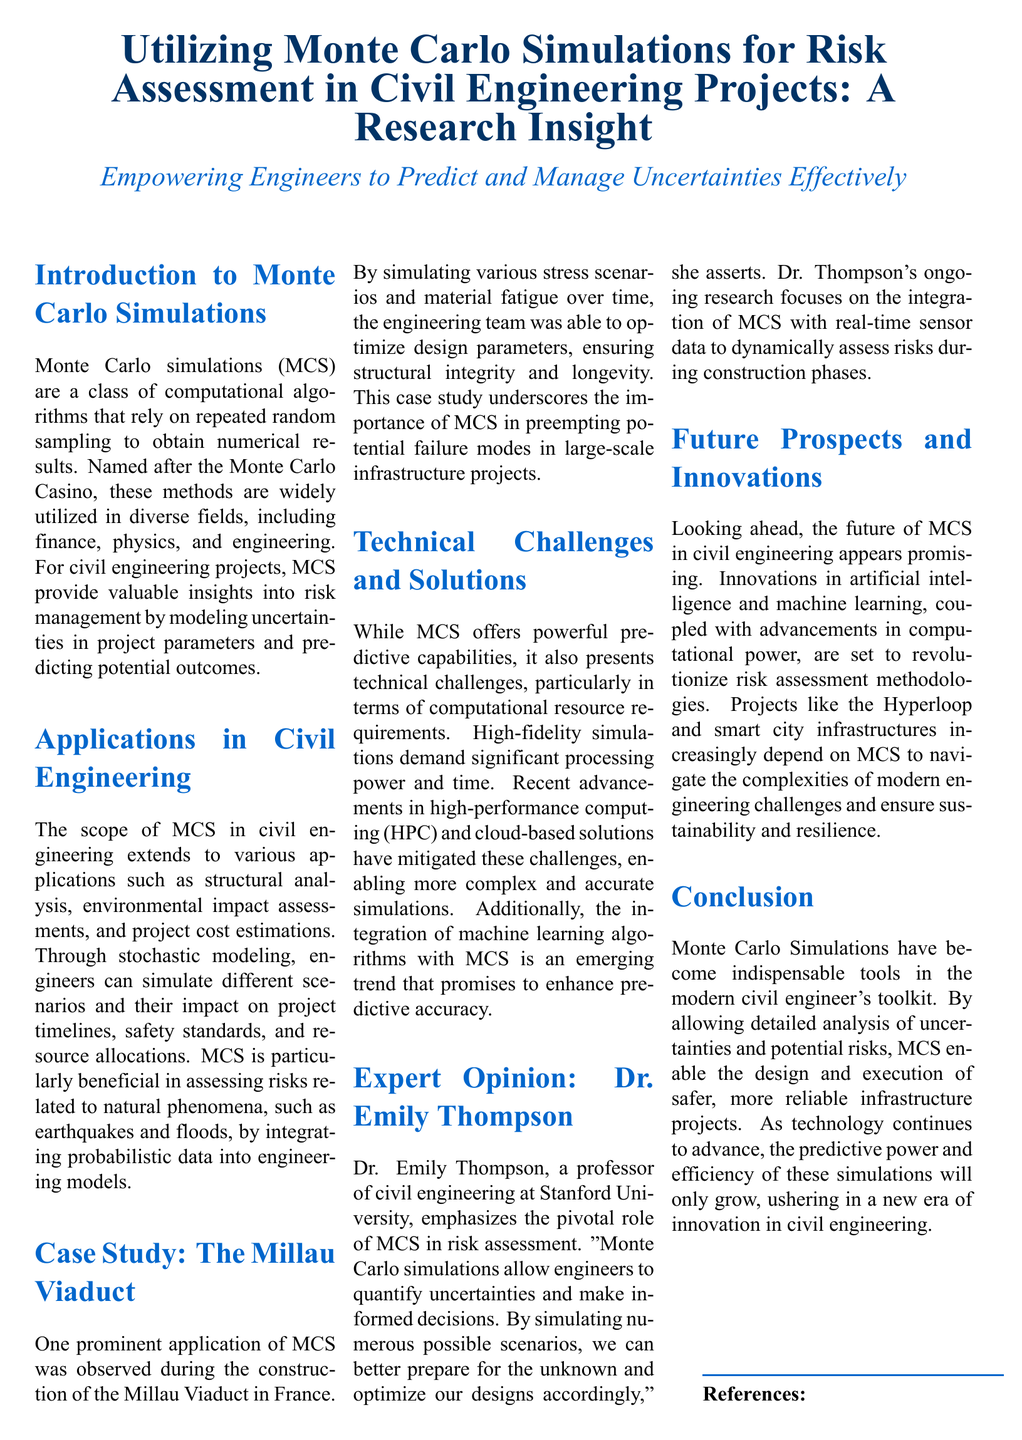What is the main title of the document? The main title can be found at the top of the document and concisely summarizes the content, focusing on Monte Carlo simulations.
Answer: Utilizing Monte Carlo Simulations for Risk Assessment in Civil Engineering Projects: A Research Insight Who is the expert quoted in the document? The expert's name is mentioned under the "Expert Opinion" section of the document.
Answer: Dr. Emily Thompson What was a significant application of Monte Carlo simulations mentioned in the document? The document provides a specific case study illustrating the application of MCS in a famous civil engineering project.
Answer: The Millau Viaduct What are two fields where Monte Carlo simulations are utilized, as stated in the document? The document lists various fields that employ MCS at the beginning, highlighting its versatility.
Answer: Finance, physics What does MCS stand for? The abbreviation is defined in the "Introduction to Monte Carlo Simulations" section as part of explaining the concept.
Answer: Monte Carlo Simulations What is the main advantage of integrating machine learning with MCS, according to the document? The document discusses emerging trends and potential benefits of combining these technologies.
Answer: Enhance predictive accuracy What challenges do Monte Carlo simulations commonly face? The document outlines specific difficulties in using MCS, particularly related to technical aspects.
Answer: Computational resource requirements What future advancements are anticipated in the field of MCS for civil engineering? The document mentions specific innovations that could influence the future of MCS in civil engineering.
Answer: Artificial intelligence and machine learning 